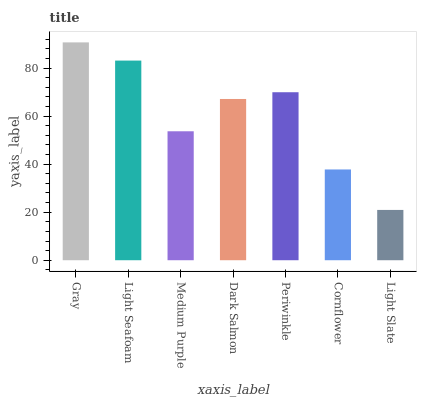Is Light Slate the minimum?
Answer yes or no. Yes. Is Gray the maximum?
Answer yes or no. Yes. Is Light Seafoam the minimum?
Answer yes or no. No. Is Light Seafoam the maximum?
Answer yes or no. No. Is Gray greater than Light Seafoam?
Answer yes or no. Yes. Is Light Seafoam less than Gray?
Answer yes or no. Yes. Is Light Seafoam greater than Gray?
Answer yes or no. No. Is Gray less than Light Seafoam?
Answer yes or no. No. Is Dark Salmon the high median?
Answer yes or no. Yes. Is Dark Salmon the low median?
Answer yes or no. Yes. Is Light Seafoam the high median?
Answer yes or no. No. Is Periwinkle the low median?
Answer yes or no. No. 